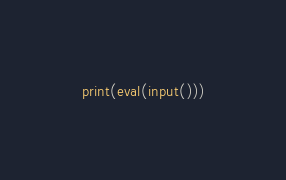<code> <loc_0><loc_0><loc_500><loc_500><_Python_>print(eval(input()))</code> 